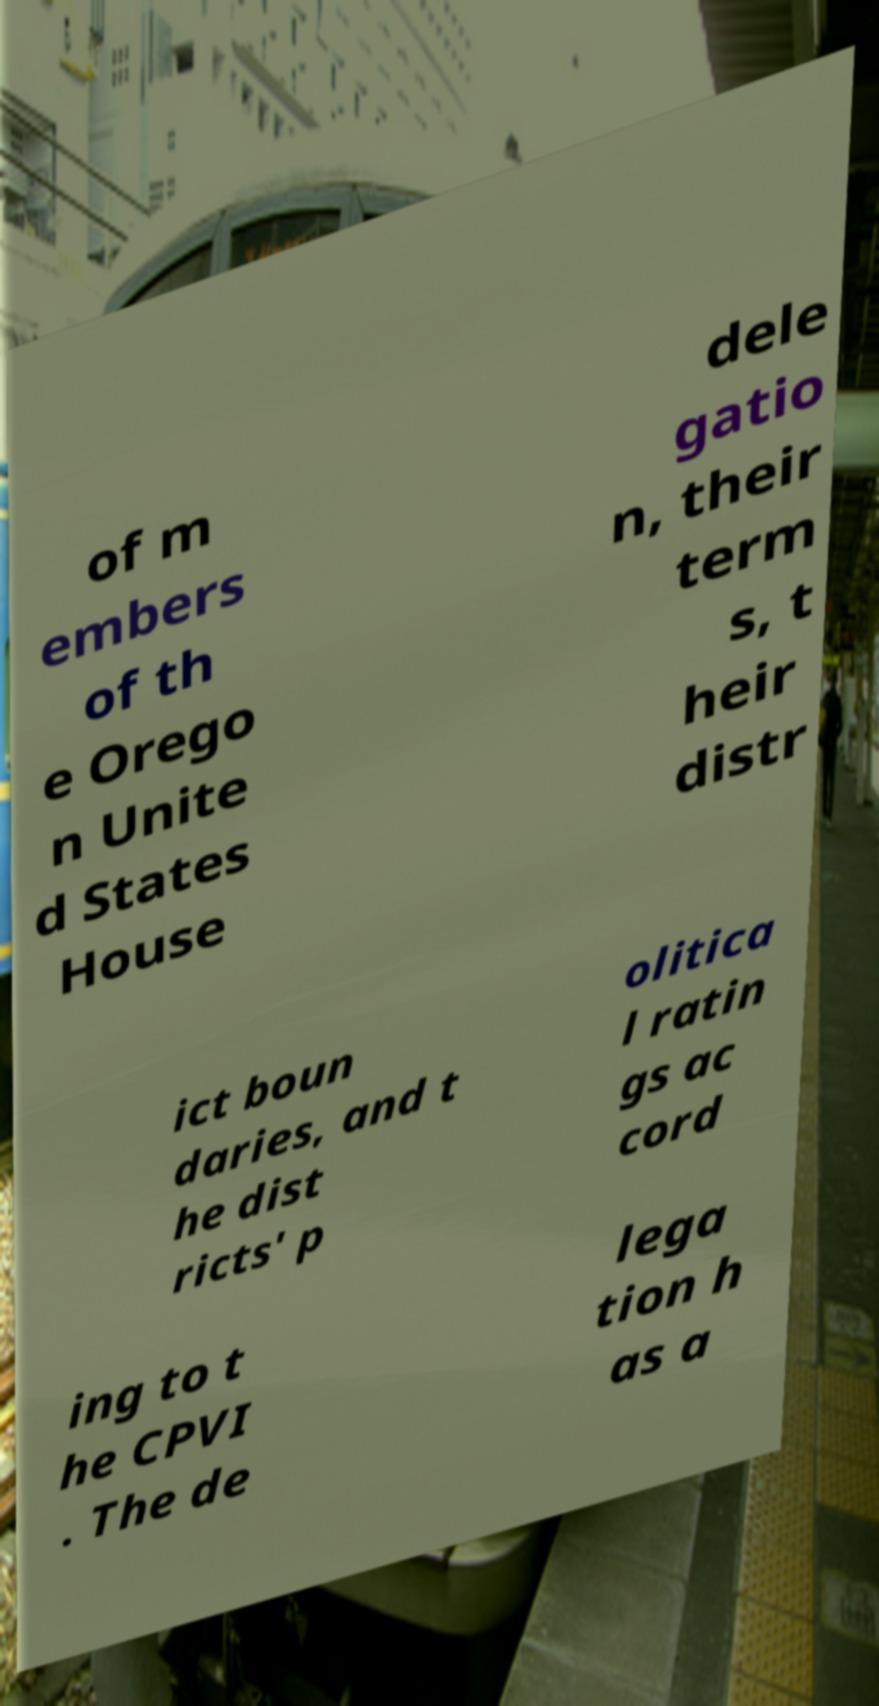Can you accurately transcribe the text from the provided image for me? of m embers of th e Orego n Unite d States House dele gatio n, their term s, t heir distr ict boun daries, and t he dist ricts' p olitica l ratin gs ac cord ing to t he CPVI . The de lega tion h as a 